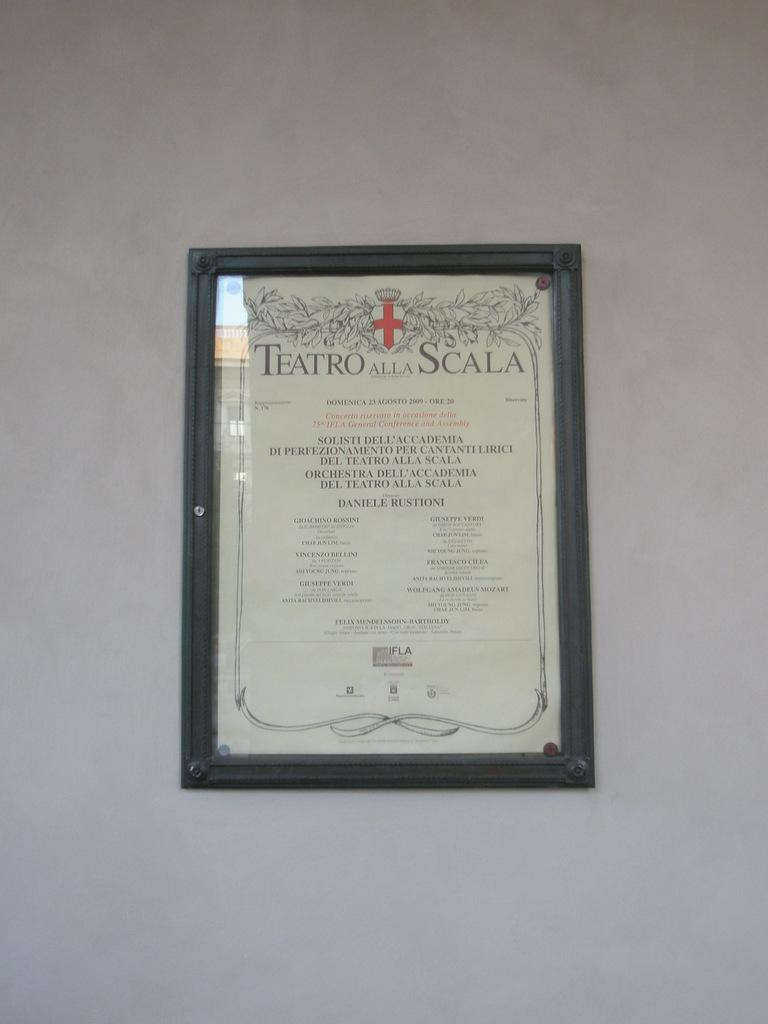Provide a one-sentence caption for the provided image. The menu lists food items from Teatro Alla Scala. 